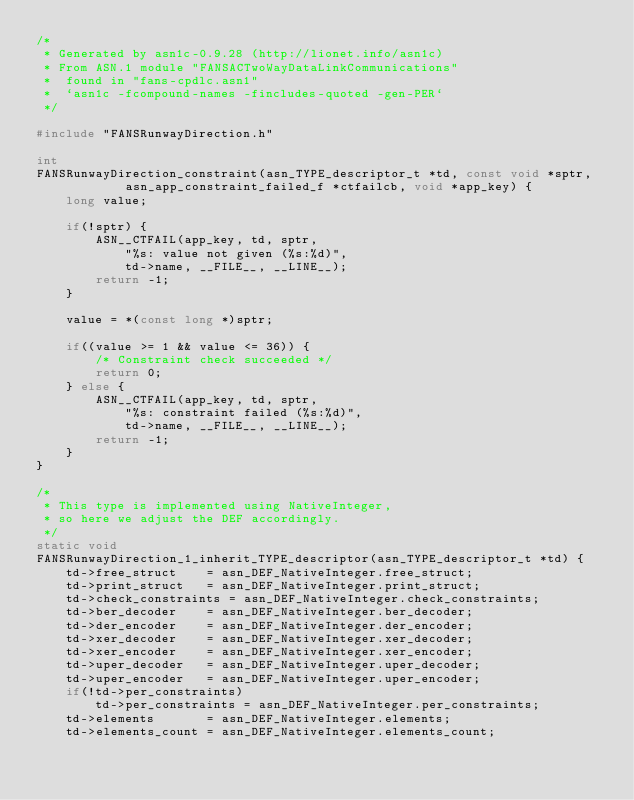Convert code to text. <code><loc_0><loc_0><loc_500><loc_500><_C_>/*
 * Generated by asn1c-0.9.28 (http://lionet.info/asn1c)
 * From ASN.1 module "FANSACTwoWayDataLinkCommunications"
 * 	found in "fans-cpdlc.asn1"
 * 	`asn1c -fcompound-names -fincludes-quoted -gen-PER`
 */

#include "FANSRunwayDirection.h"

int
FANSRunwayDirection_constraint(asn_TYPE_descriptor_t *td, const void *sptr,
			asn_app_constraint_failed_f *ctfailcb, void *app_key) {
	long value;
	
	if(!sptr) {
		ASN__CTFAIL(app_key, td, sptr,
			"%s: value not given (%s:%d)",
			td->name, __FILE__, __LINE__);
		return -1;
	}
	
	value = *(const long *)sptr;
	
	if((value >= 1 && value <= 36)) {
		/* Constraint check succeeded */
		return 0;
	} else {
		ASN__CTFAIL(app_key, td, sptr,
			"%s: constraint failed (%s:%d)",
			td->name, __FILE__, __LINE__);
		return -1;
	}
}

/*
 * This type is implemented using NativeInteger,
 * so here we adjust the DEF accordingly.
 */
static void
FANSRunwayDirection_1_inherit_TYPE_descriptor(asn_TYPE_descriptor_t *td) {
	td->free_struct    = asn_DEF_NativeInteger.free_struct;
	td->print_struct   = asn_DEF_NativeInteger.print_struct;
	td->check_constraints = asn_DEF_NativeInteger.check_constraints;
	td->ber_decoder    = asn_DEF_NativeInteger.ber_decoder;
	td->der_encoder    = asn_DEF_NativeInteger.der_encoder;
	td->xer_decoder    = asn_DEF_NativeInteger.xer_decoder;
	td->xer_encoder    = asn_DEF_NativeInteger.xer_encoder;
	td->uper_decoder   = asn_DEF_NativeInteger.uper_decoder;
	td->uper_encoder   = asn_DEF_NativeInteger.uper_encoder;
	if(!td->per_constraints)
		td->per_constraints = asn_DEF_NativeInteger.per_constraints;
	td->elements       = asn_DEF_NativeInteger.elements;
	td->elements_count = asn_DEF_NativeInteger.elements_count;</code> 